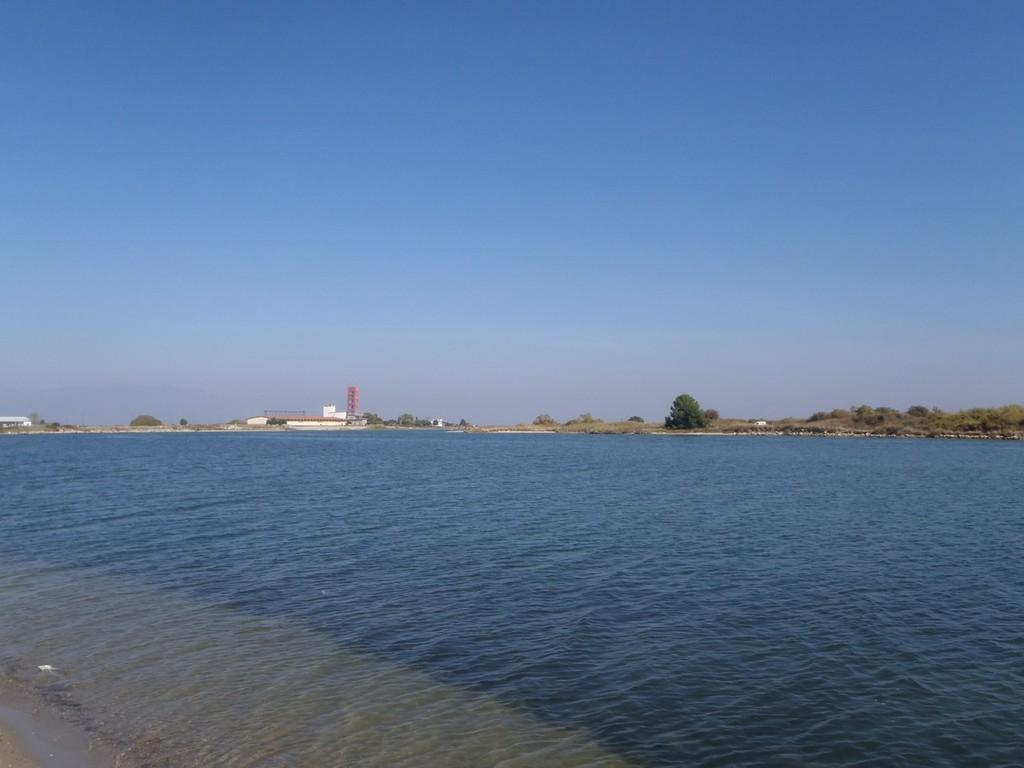What can be seen in the front of the image? There is a sea in the front of the image. What type of vegetation is present on the land in the image? There are trees on the land in the image. What structure is visible in the image? There is a tower in the image. What type of man-made structure can be seen in the image? There is a building in the image. What is visible above the land and sea in the image? The sky is visible in the image. What type of mouth can be seen on the tower in the image? There is no mouth present on the tower in the image. What type of yam is growing near the sea in the image? There is no yam present in the image. 